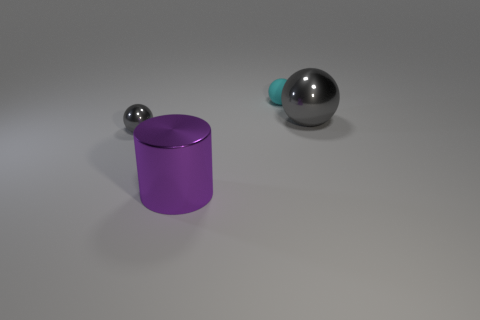Are there any other things that have the same material as the small cyan thing?
Ensure brevity in your answer.  No. There is a large thing that is the same color as the small shiny thing; what is it made of?
Your answer should be very brief. Metal. What size is the thing that is the same color as the large shiny sphere?
Make the answer very short. Small. What number of cylinders have the same material as the tiny gray thing?
Ensure brevity in your answer.  1. Are there any big green objects?
Give a very brief answer. No. There is a metal thing in front of the tiny gray metal sphere; how big is it?
Your response must be concise. Large. How many other large metallic cylinders are the same color as the cylinder?
Give a very brief answer. 0. What number of balls are either small brown metal things or big purple metal things?
Offer a very short reply. 0. The thing that is in front of the small cyan matte thing and behind the tiny gray metallic thing has what shape?
Offer a terse response. Sphere. Is there another purple cylinder of the same size as the shiny cylinder?
Provide a succinct answer. No. 